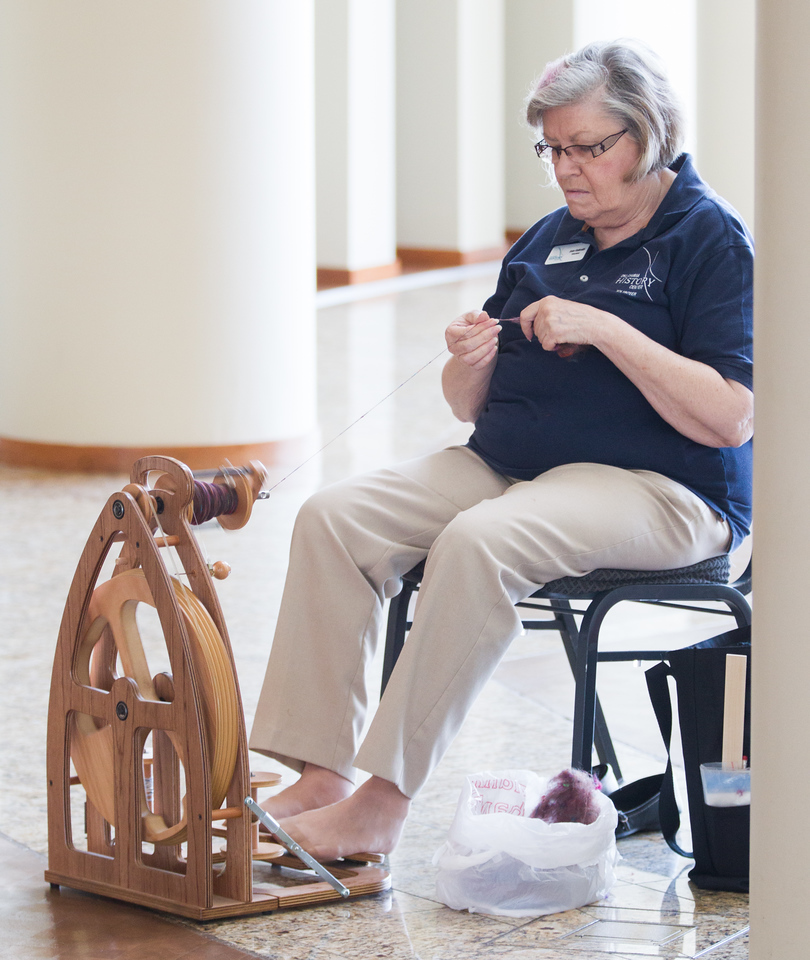What is she making with the yarn she is spinning? The woman could be spinning yarn for a variety of projects such as knitting a sweater, weaving a tapestry, or creating a handmade scarf. Given the precision in her work, it's likely she is preparing the yarn for a specific, skillful project that requires high-quality hand-spun yarn. How long might it take to produce enough yarn for a sweater? Producing enough yarn for a sweater can take a significant amount of time, depending on the thickness of the yarn and the speed of the spinner. For an average adult-sized sweater, it might take anywhere from 10 to 30 hours of spinning to create enough yarn, not including the time needed to prepare, dye, and finish the yarn. This process requires patience and dedication, reflecting the spinner's commitment to their craft. What's a creative application for hand-spun yarn? A highly creative application for hand-spun yarn is to use it in creating textured art pieces. For instance, the yarn can be incorporated into mixed media artworks, combined with paint, fabric, and other materials to create a visually stunning and tactile art piece. The uniqueness of hand-spun yarn, with its slight variations in thickness and color, can add depth and character to such projects, making each piece truly one-of-a-kind. 